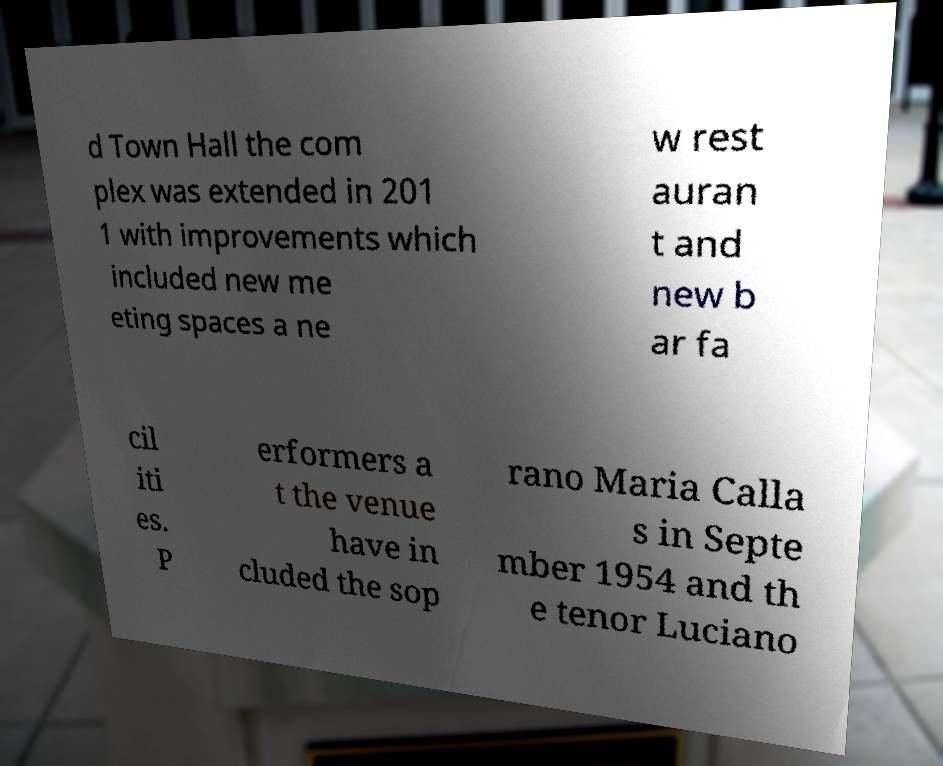There's text embedded in this image that I need extracted. Can you transcribe it verbatim? d Town Hall the com plex was extended in 201 1 with improvements which included new me eting spaces a ne w rest auran t and new b ar fa cil iti es. P erformers a t the venue have in cluded the sop rano Maria Calla s in Septe mber 1954 and th e tenor Luciano 